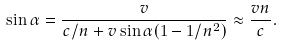Convert formula to latex. <formula><loc_0><loc_0><loc_500><loc_500>\sin \alpha = \frac { v } { c / n + v \sin \alpha ( 1 - 1 / n ^ { 2 } ) } \approx \frac { v n } { c } .</formula> 